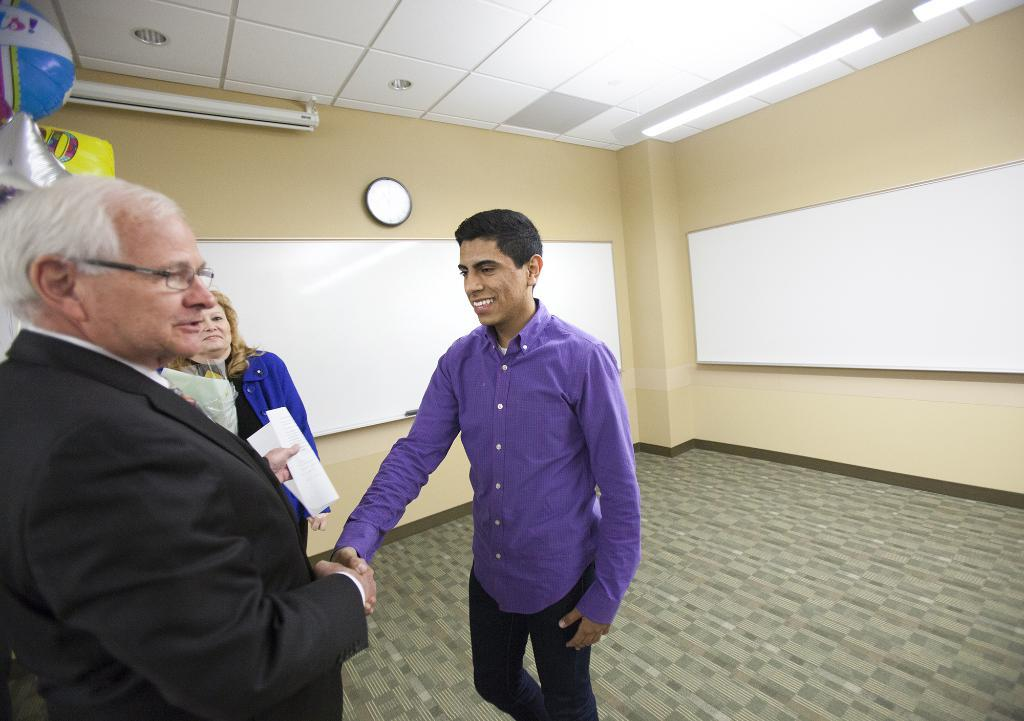How many people are in the image? There are people in the image, but the exact number is not specified. What are some of the people holding in the image? Some of the people are holding papers in the image. What type of lighting is visible in the image? Ceiling lights are visible in the image. What is the large, flat surface in the image used for? There is a projector screen in the image, which is likely used for presentations or displays. What decorative items can be seen in the image? Balloons are present in the image, along with other objects on the wall. What type of animal can be seen brushing its fur on the projector screen in the image? There are no animals present in the image, and the projector screen is not being used for any grooming activities. 